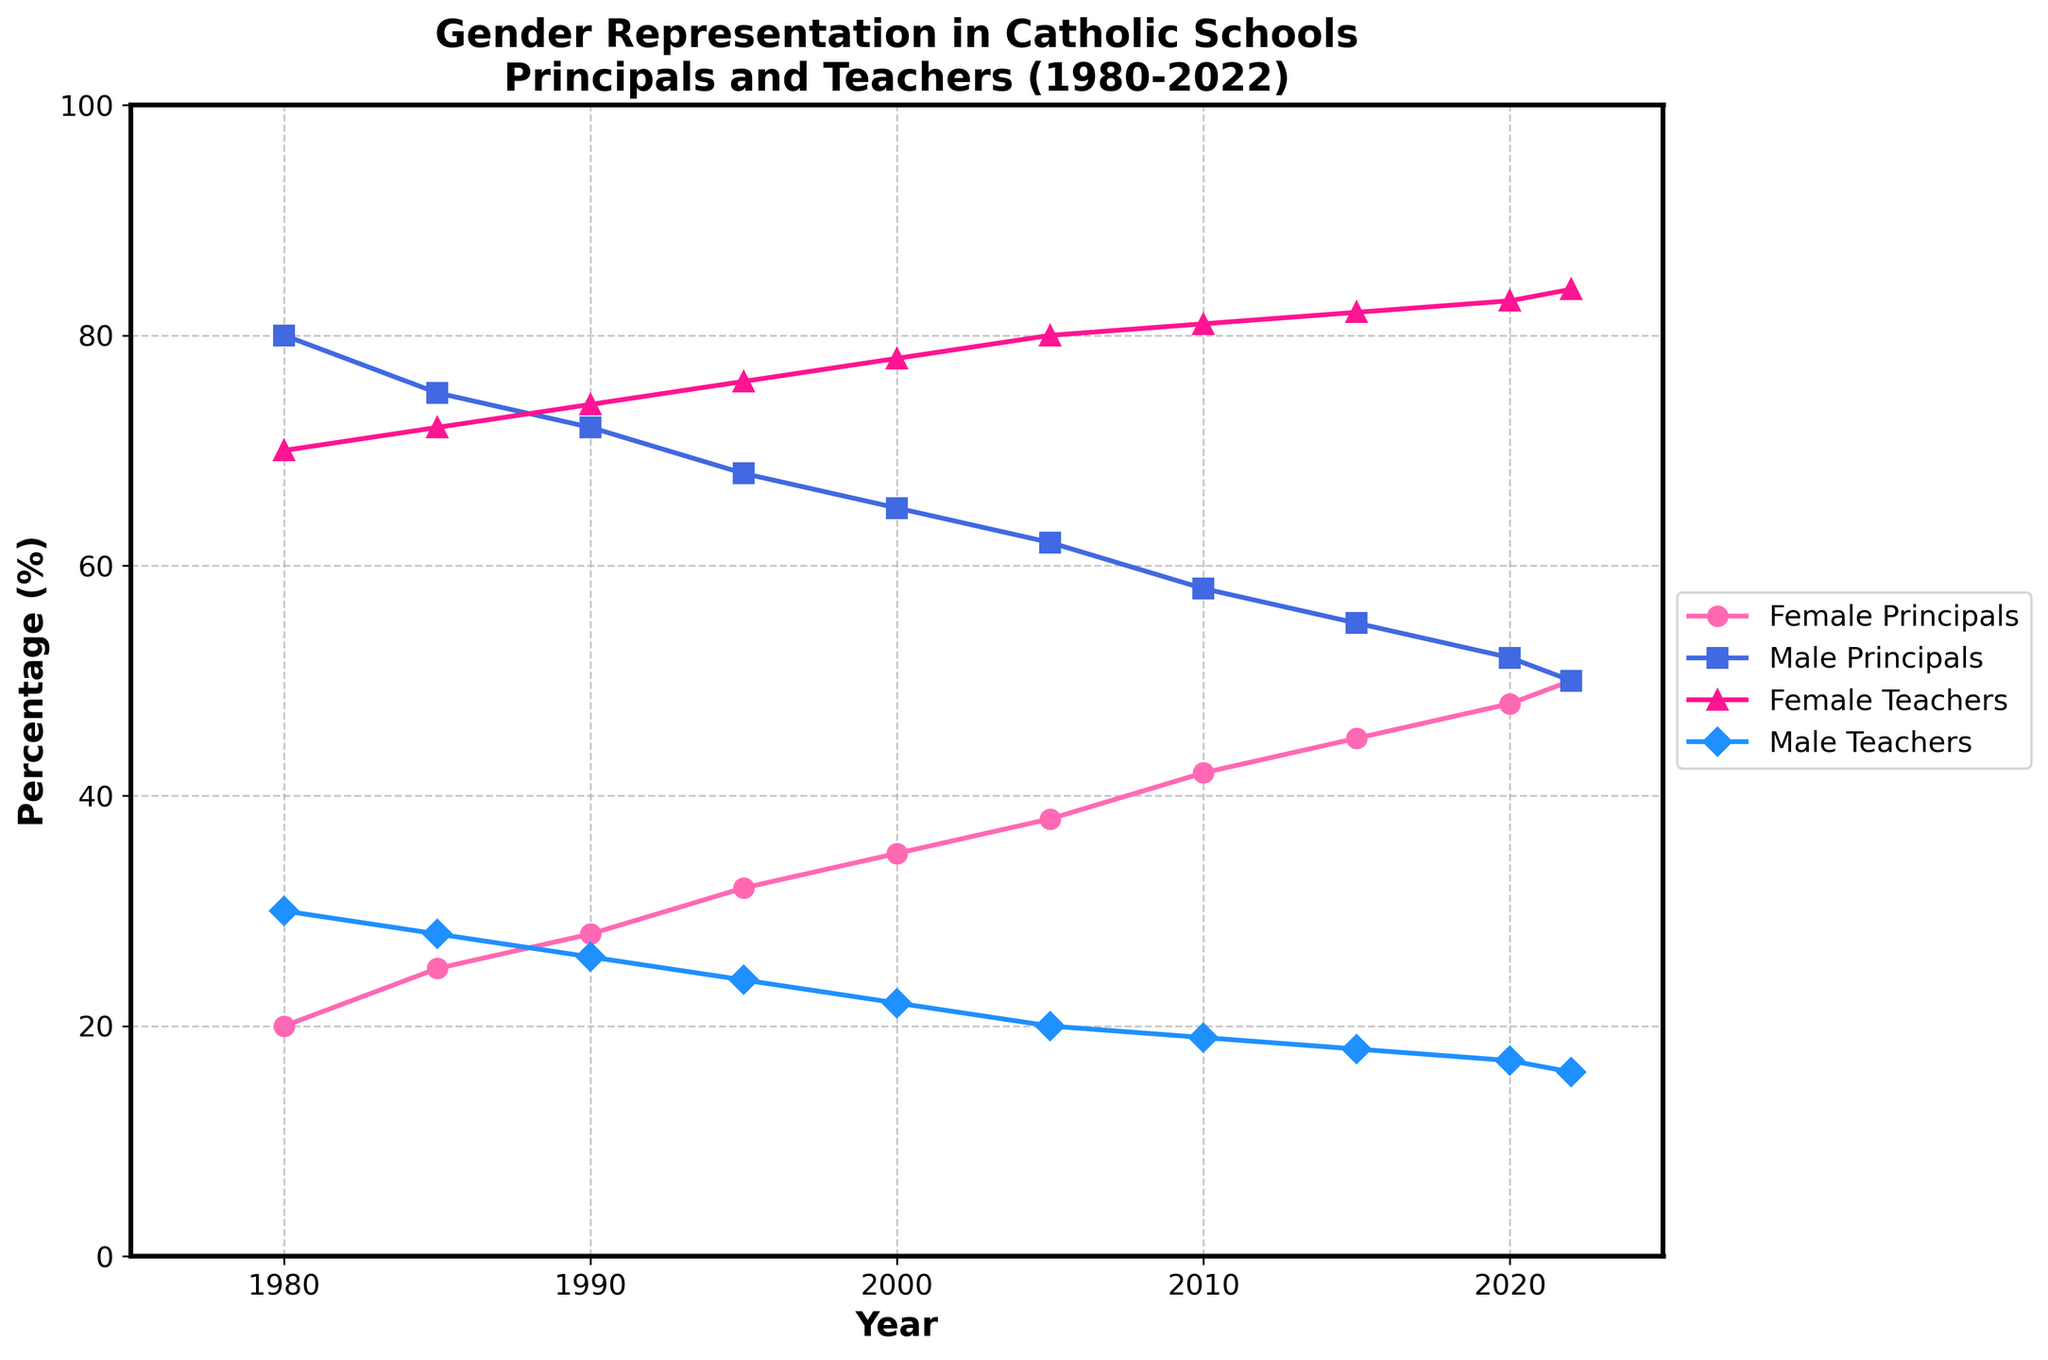How has the percentage of female principals in Catholic schools changed from 1980 to 2022? The figure shows an upward trend in the percentage of female principals in Catholic schools. In 1980, the percentage was 20%, and it increased steadily to 50% by 2022.
Answer: Increased from 20% to 50% What is the difference between the percentage of female and male principals in Catholic schools in 2000? In 2000, the percentage of female principals was 35%, and the percentage of male principals was 65%. The difference is calculated as 65% - 35%.
Answer: 30% Which gender had a higher percentage of teachers in Catholic schools in 2020? In 2020, the figure shows that female teachers had a higher percentage compared to male teachers. The percentage of female teachers was 83%, whereas the percentage of male teachers was 17%.
Answer: Female In which year did the percentage of female principals reach 45% in Catholic schools? The figure indicates that the percentage of female principals in Catholic schools reached 45% in the year 2015.
Answer: 2015 What trend can be observed about male teachers in Catholic schools over the years from 1980 to 2022? The percentage of male teachers in Catholic schools shows a declining trend over the indicated years. Starting at 30% in 1980, it gradually decreases to 16% by 2022.
Answer: Decline What is the total percentage of female staff (both principals and teachers) in Catholic schools in 2010? In 2010, the percentage of female principals is 42%, and the percentage of female teachers is 81%. The total percentage of female staff can be calculated as 42% + 81% = 123%.
Answer: 123% Which year marks an equal representation of male and female principals in Catholic schools? The figure shows that in the year 2022, the percentage of male and female principals are equal, each at 50%.
Answer: 2022 Compare the percentage increase of female teachers and female principals from 1980 to 2022. Which group had a higher increase? From 1980 to 2022, the percentage of female teachers increased from 70% to 84%, which is an increase of 14%. For female principals, the percentage increased from 20% to 50%, which is an increase of 30%. Therefore, female principals had a higher percentage increase.
Answer: Female principals What happens to the percentage of male principals and male teachers over time? Both the percentage of male principals and the percentage of male teachers show a decreasing trend over time. Male principals decrease from 80% in 1980 to 50% in 2022. Male teachers decrease from 30% in 1980 to 16% in 2022.
Answer: Decrease 